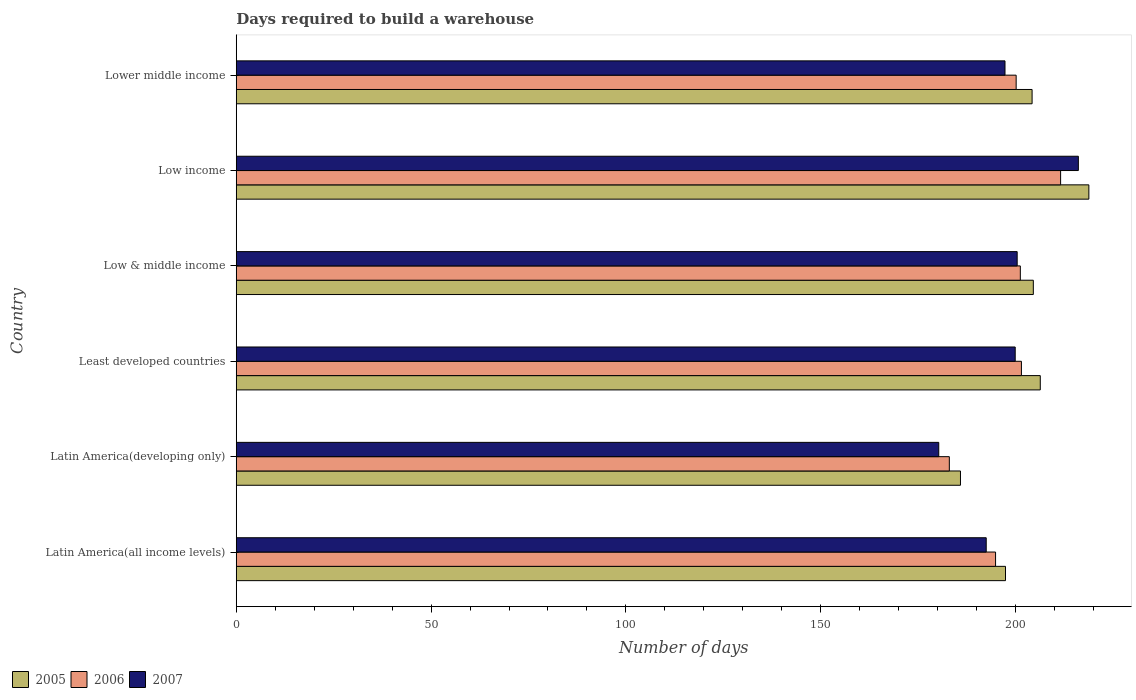Are the number of bars per tick equal to the number of legend labels?
Provide a short and direct response. Yes. Are the number of bars on each tick of the Y-axis equal?
Provide a short and direct response. Yes. How many bars are there on the 4th tick from the top?
Offer a terse response. 3. How many bars are there on the 3rd tick from the bottom?
Make the answer very short. 3. What is the label of the 1st group of bars from the top?
Your answer should be compact. Lower middle income. What is the days required to build a warehouse in in 2007 in Least developed countries?
Your answer should be very brief. 199.9. Across all countries, what is the maximum days required to build a warehouse in in 2007?
Offer a terse response. 216.11. Across all countries, what is the minimum days required to build a warehouse in in 2006?
Offer a terse response. 183. In which country was the days required to build a warehouse in in 2006 maximum?
Ensure brevity in your answer.  Low income. In which country was the days required to build a warehouse in in 2005 minimum?
Offer a terse response. Latin America(developing only). What is the total days required to build a warehouse in in 2007 in the graph?
Offer a very short reply. 1186.46. What is the difference between the days required to build a warehouse in in 2005 in Latin America(all income levels) and that in Low income?
Your answer should be compact. -21.39. What is the difference between the days required to build a warehouse in in 2007 in Lower middle income and the days required to build a warehouse in in 2005 in Least developed countries?
Provide a short and direct response. -9.06. What is the average days required to build a warehouse in in 2006 per country?
Your answer should be very brief. 198.71. What is the difference between the days required to build a warehouse in in 2007 and days required to build a warehouse in in 2005 in Lower middle income?
Offer a terse response. -6.95. In how many countries, is the days required to build a warehouse in in 2007 greater than 110 days?
Ensure brevity in your answer.  6. What is the ratio of the days required to build a warehouse in in 2006 in Latin America(all income levels) to that in Low & middle income?
Keep it short and to the point. 0.97. Is the difference between the days required to build a warehouse in in 2007 in Latin America(all income levels) and Low income greater than the difference between the days required to build a warehouse in in 2005 in Latin America(all income levels) and Low income?
Your answer should be very brief. No. What is the difference between the highest and the second highest days required to build a warehouse in in 2005?
Provide a succinct answer. 12.47. What is the difference between the highest and the lowest days required to build a warehouse in in 2006?
Your answer should be very brief. 28.56. In how many countries, is the days required to build a warehouse in in 2005 greater than the average days required to build a warehouse in in 2005 taken over all countries?
Ensure brevity in your answer.  4. Is it the case that in every country, the sum of the days required to build a warehouse in in 2006 and days required to build a warehouse in in 2005 is greater than the days required to build a warehouse in in 2007?
Provide a short and direct response. Yes. What is the difference between two consecutive major ticks on the X-axis?
Provide a short and direct response. 50. Are the values on the major ticks of X-axis written in scientific E-notation?
Your answer should be very brief. No. Does the graph contain grids?
Keep it short and to the point. No. Where does the legend appear in the graph?
Provide a succinct answer. Bottom left. What is the title of the graph?
Keep it short and to the point. Days required to build a warehouse. What is the label or title of the X-axis?
Your answer should be compact. Number of days. What is the label or title of the Y-axis?
Provide a succinct answer. Country. What is the Number of days of 2005 in Latin America(all income levels)?
Provide a succinct answer. 197.41. What is the Number of days in 2006 in Latin America(all income levels)?
Make the answer very short. 194.86. What is the Number of days of 2007 in Latin America(all income levels)?
Make the answer very short. 192.47. What is the Number of days in 2005 in Latin America(developing only)?
Make the answer very short. 185.86. What is the Number of days of 2006 in Latin America(developing only)?
Your response must be concise. 183. What is the Number of days in 2007 in Latin America(developing only)?
Provide a short and direct response. 180.29. What is the Number of days in 2005 in Least developed countries?
Give a very brief answer. 206.34. What is the Number of days of 2006 in Least developed countries?
Give a very brief answer. 201.5. What is the Number of days of 2007 in Least developed countries?
Provide a short and direct response. 199.9. What is the Number of days of 2005 in Low & middle income?
Your answer should be compact. 204.56. What is the Number of days of 2006 in Low & middle income?
Give a very brief answer. 201.22. What is the Number of days of 2007 in Low & middle income?
Make the answer very short. 200.41. What is the Number of days of 2005 in Low income?
Your answer should be very brief. 218.81. What is the Number of days of 2006 in Low income?
Keep it short and to the point. 211.56. What is the Number of days in 2007 in Low income?
Offer a terse response. 216.11. What is the Number of days of 2005 in Lower middle income?
Your answer should be very brief. 204.24. What is the Number of days in 2006 in Lower middle income?
Keep it short and to the point. 200.15. What is the Number of days of 2007 in Lower middle income?
Keep it short and to the point. 197.28. Across all countries, what is the maximum Number of days in 2005?
Your answer should be compact. 218.81. Across all countries, what is the maximum Number of days in 2006?
Your response must be concise. 211.56. Across all countries, what is the maximum Number of days of 2007?
Ensure brevity in your answer.  216.11. Across all countries, what is the minimum Number of days of 2005?
Provide a short and direct response. 185.86. Across all countries, what is the minimum Number of days in 2006?
Your answer should be compact. 183. Across all countries, what is the minimum Number of days of 2007?
Your answer should be very brief. 180.29. What is the total Number of days of 2005 in the graph?
Your response must be concise. 1217.22. What is the total Number of days in 2006 in the graph?
Make the answer very short. 1192.29. What is the total Number of days in 2007 in the graph?
Make the answer very short. 1186.46. What is the difference between the Number of days in 2005 in Latin America(all income levels) and that in Latin America(developing only)?
Provide a short and direct response. 11.56. What is the difference between the Number of days of 2006 in Latin America(all income levels) and that in Latin America(developing only)?
Your response must be concise. 11.86. What is the difference between the Number of days in 2007 in Latin America(all income levels) and that in Latin America(developing only)?
Your response must be concise. 12.18. What is the difference between the Number of days in 2005 in Latin America(all income levels) and that in Least developed countries?
Keep it short and to the point. -8.93. What is the difference between the Number of days of 2006 in Latin America(all income levels) and that in Least developed countries?
Give a very brief answer. -6.64. What is the difference between the Number of days of 2007 in Latin America(all income levels) and that in Least developed countries?
Your answer should be compact. -7.44. What is the difference between the Number of days in 2005 in Latin America(all income levels) and that in Low & middle income?
Offer a very short reply. -7.14. What is the difference between the Number of days in 2006 in Latin America(all income levels) and that in Low & middle income?
Provide a short and direct response. -6.36. What is the difference between the Number of days in 2007 in Latin America(all income levels) and that in Low & middle income?
Keep it short and to the point. -7.94. What is the difference between the Number of days of 2005 in Latin America(all income levels) and that in Low income?
Provide a short and direct response. -21.39. What is the difference between the Number of days of 2006 in Latin America(all income levels) and that in Low income?
Your answer should be very brief. -16.69. What is the difference between the Number of days in 2007 in Latin America(all income levels) and that in Low income?
Give a very brief answer. -23.64. What is the difference between the Number of days of 2005 in Latin America(all income levels) and that in Lower middle income?
Your answer should be very brief. -6.82. What is the difference between the Number of days in 2006 in Latin America(all income levels) and that in Lower middle income?
Offer a very short reply. -5.29. What is the difference between the Number of days of 2007 in Latin America(all income levels) and that in Lower middle income?
Your answer should be very brief. -4.82. What is the difference between the Number of days in 2005 in Latin America(developing only) and that in Least developed countries?
Provide a short and direct response. -20.48. What is the difference between the Number of days of 2006 in Latin America(developing only) and that in Least developed countries?
Offer a terse response. -18.5. What is the difference between the Number of days of 2007 in Latin America(developing only) and that in Least developed countries?
Give a very brief answer. -19.62. What is the difference between the Number of days of 2005 in Latin America(developing only) and that in Low & middle income?
Provide a succinct answer. -18.7. What is the difference between the Number of days in 2006 in Latin America(developing only) and that in Low & middle income?
Ensure brevity in your answer.  -18.22. What is the difference between the Number of days in 2007 in Latin America(developing only) and that in Low & middle income?
Your answer should be compact. -20.12. What is the difference between the Number of days in 2005 in Latin America(developing only) and that in Low income?
Provide a short and direct response. -32.95. What is the difference between the Number of days in 2006 in Latin America(developing only) and that in Low income?
Provide a succinct answer. -28.56. What is the difference between the Number of days of 2007 in Latin America(developing only) and that in Low income?
Give a very brief answer. -35.83. What is the difference between the Number of days of 2005 in Latin America(developing only) and that in Lower middle income?
Provide a short and direct response. -18.38. What is the difference between the Number of days in 2006 in Latin America(developing only) and that in Lower middle income?
Make the answer very short. -17.15. What is the difference between the Number of days in 2007 in Latin America(developing only) and that in Lower middle income?
Offer a terse response. -17. What is the difference between the Number of days in 2005 in Least developed countries and that in Low & middle income?
Your answer should be compact. 1.78. What is the difference between the Number of days of 2006 in Least developed countries and that in Low & middle income?
Provide a short and direct response. 0.28. What is the difference between the Number of days in 2007 in Least developed countries and that in Low & middle income?
Offer a very short reply. -0.5. What is the difference between the Number of days in 2005 in Least developed countries and that in Low income?
Your answer should be compact. -12.47. What is the difference between the Number of days in 2006 in Least developed countries and that in Low income?
Your response must be concise. -10.06. What is the difference between the Number of days of 2007 in Least developed countries and that in Low income?
Your answer should be compact. -16.21. What is the difference between the Number of days of 2005 in Least developed countries and that in Lower middle income?
Your answer should be compact. 2.1. What is the difference between the Number of days in 2006 in Least developed countries and that in Lower middle income?
Offer a terse response. 1.35. What is the difference between the Number of days of 2007 in Least developed countries and that in Lower middle income?
Provide a succinct answer. 2.62. What is the difference between the Number of days of 2005 in Low & middle income and that in Low income?
Provide a short and direct response. -14.25. What is the difference between the Number of days of 2006 in Low & middle income and that in Low income?
Make the answer very short. -10.34. What is the difference between the Number of days in 2007 in Low & middle income and that in Low income?
Make the answer very short. -15.7. What is the difference between the Number of days in 2005 in Low & middle income and that in Lower middle income?
Offer a very short reply. 0.32. What is the difference between the Number of days of 2006 in Low & middle income and that in Lower middle income?
Offer a terse response. 1.07. What is the difference between the Number of days in 2007 in Low & middle income and that in Lower middle income?
Your response must be concise. 3.13. What is the difference between the Number of days in 2005 in Low income and that in Lower middle income?
Offer a very short reply. 14.57. What is the difference between the Number of days of 2006 in Low income and that in Lower middle income?
Offer a terse response. 11.41. What is the difference between the Number of days of 2007 in Low income and that in Lower middle income?
Keep it short and to the point. 18.83. What is the difference between the Number of days in 2005 in Latin America(all income levels) and the Number of days in 2006 in Latin America(developing only)?
Give a very brief answer. 14.41. What is the difference between the Number of days of 2005 in Latin America(all income levels) and the Number of days of 2007 in Latin America(developing only)?
Your answer should be compact. 17.13. What is the difference between the Number of days of 2006 in Latin America(all income levels) and the Number of days of 2007 in Latin America(developing only)?
Offer a terse response. 14.58. What is the difference between the Number of days in 2005 in Latin America(all income levels) and the Number of days in 2006 in Least developed countries?
Give a very brief answer. -4.09. What is the difference between the Number of days of 2005 in Latin America(all income levels) and the Number of days of 2007 in Least developed countries?
Ensure brevity in your answer.  -2.49. What is the difference between the Number of days in 2006 in Latin America(all income levels) and the Number of days in 2007 in Least developed countries?
Provide a short and direct response. -5.04. What is the difference between the Number of days in 2005 in Latin America(all income levels) and the Number of days in 2006 in Low & middle income?
Ensure brevity in your answer.  -3.81. What is the difference between the Number of days in 2005 in Latin America(all income levels) and the Number of days in 2007 in Low & middle income?
Ensure brevity in your answer.  -3. What is the difference between the Number of days in 2006 in Latin America(all income levels) and the Number of days in 2007 in Low & middle income?
Provide a succinct answer. -5.55. What is the difference between the Number of days in 2005 in Latin America(all income levels) and the Number of days in 2006 in Low income?
Offer a terse response. -14.14. What is the difference between the Number of days of 2005 in Latin America(all income levels) and the Number of days of 2007 in Low income?
Give a very brief answer. -18.7. What is the difference between the Number of days of 2006 in Latin America(all income levels) and the Number of days of 2007 in Low income?
Your response must be concise. -21.25. What is the difference between the Number of days of 2005 in Latin America(all income levels) and the Number of days of 2006 in Lower middle income?
Keep it short and to the point. -2.73. What is the difference between the Number of days in 2005 in Latin America(all income levels) and the Number of days in 2007 in Lower middle income?
Your response must be concise. 0.13. What is the difference between the Number of days in 2006 in Latin America(all income levels) and the Number of days in 2007 in Lower middle income?
Your answer should be compact. -2.42. What is the difference between the Number of days in 2005 in Latin America(developing only) and the Number of days in 2006 in Least developed countries?
Give a very brief answer. -15.64. What is the difference between the Number of days of 2005 in Latin America(developing only) and the Number of days of 2007 in Least developed countries?
Keep it short and to the point. -14.05. What is the difference between the Number of days in 2006 in Latin America(developing only) and the Number of days in 2007 in Least developed countries?
Your answer should be very brief. -16.9. What is the difference between the Number of days in 2005 in Latin America(developing only) and the Number of days in 2006 in Low & middle income?
Provide a short and direct response. -15.36. What is the difference between the Number of days in 2005 in Latin America(developing only) and the Number of days in 2007 in Low & middle income?
Offer a terse response. -14.55. What is the difference between the Number of days in 2006 in Latin America(developing only) and the Number of days in 2007 in Low & middle income?
Keep it short and to the point. -17.41. What is the difference between the Number of days of 2005 in Latin America(developing only) and the Number of days of 2006 in Low income?
Offer a very short reply. -25.7. What is the difference between the Number of days of 2005 in Latin America(developing only) and the Number of days of 2007 in Low income?
Make the answer very short. -30.25. What is the difference between the Number of days in 2006 in Latin America(developing only) and the Number of days in 2007 in Low income?
Your answer should be very brief. -33.11. What is the difference between the Number of days of 2005 in Latin America(developing only) and the Number of days of 2006 in Lower middle income?
Your answer should be very brief. -14.29. What is the difference between the Number of days of 2005 in Latin America(developing only) and the Number of days of 2007 in Lower middle income?
Give a very brief answer. -11.43. What is the difference between the Number of days in 2006 in Latin America(developing only) and the Number of days in 2007 in Lower middle income?
Keep it short and to the point. -14.28. What is the difference between the Number of days of 2005 in Least developed countries and the Number of days of 2006 in Low & middle income?
Your response must be concise. 5.12. What is the difference between the Number of days in 2005 in Least developed countries and the Number of days in 2007 in Low & middle income?
Provide a succinct answer. 5.93. What is the difference between the Number of days in 2006 in Least developed countries and the Number of days in 2007 in Low & middle income?
Provide a short and direct response. 1.09. What is the difference between the Number of days of 2005 in Least developed countries and the Number of days of 2006 in Low income?
Provide a succinct answer. -5.21. What is the difference between the Number of days in 2005 in Least developed countries and the Number of days in 2007 in Low income?
Provide a short and direct response. -9.77. What is the difference between the Number of days of 2006 in Least developed countries and the Number of days of 2007 in Low income?
Ensure brevity in your answer.  -14.61. What is the difference between the Number of days in 2005 in Least developed countries and the Number of days in 2006 in Lower middle income?
Keep it short and to the point. 6.19. What is the difference between the Number of days of 2005 in Least developed countries and the Number of days of 2007 in Lower middle income?
Ensure brevity in your answer.  9.06. What is the difference between the Number of days in 2006 in Least developed countries and the Number of days in 2007 in Lower middle income?
Your response must be concise. 4.22. What is the difference between the Number of days in 2005 in Low & middle income and the Number of days in 2006 in Low income?
Keep it short and to the point. -7. What is the difference between the Number of days of 2005 in Low & middle income and the Number of days of 2007 in Low income?
Give a very brief answer. -11.55. What is the difference between the Number of days of 2006 in Low & middle income and the Number of days of 2007 in Low income?
Provide a succinct answer. -14.89. What is the difference between the Number of days of 2005 in Low & middle income and the Number of days of 2006 in Lower middle income?
Offer a very short reply. 4.41. What is the difference between the Number of days in 2005 in Low & middle income and the Number of days in 2007 in Lower middle income?
Your response must be concise. 7.27. What is the difference between the Number of days of 2006 in Low & middle income and the Number of days of 2007 in Lower middle income?
Make the answer very short. 3.94. What is the difference between the Number of days of 2005 in Low income and the Number of days of 2006 in Lower middle income?
Your answer should be compact. 18.66. What is the difference between the Number of days of 2005 in Low income and the Number of days of 2007 in Lower middle income?
Your answer should be very brief. 21.52. What is the difference between the Number of days in 2006 in Low income and the Number of days in 2007 in Lower middle income?
Make the answer very short. 14.27. What is the average Number of days in 2005 per country?
Provide a short and direct response. 202.87. What is the average Number of days of 2006 per country?
Make the answer very short. 198.71. What is the average Number of days of 2007 per country?
Ensure brevity in your answer.  197.74. What is the difference between the Number of days of 2005 and Number of days of 2006 in Latin America(all income levels)?
Offer a very short reply. 2.55. What is the difference between the Number of days of 2005 and Number of days of 2007 in Latin America(all income levels)?
Provide a short and direct response. 4.95. What is the difference between the Number of days of 2006 and Number of days of 2007 in Latin America(all income levels)?
Your answer should be very brief. 2.4. What is the difference between the Number of days of 2005 and Number of days of 2006 in Latin America(developing only)?
Provide a succinct answer. 2.86. What is the difference between the Number of days of 2005 and Number of days of 2007 in Latin America(developing only)?
Keep it short and to the point. 5.57. What is the difference between the Number of days of 2006 and Number of days of 2007 in Latin America(developing only)?
Provide a short and direct response. 2.71. What is the difference between the Number of days in 2005 and Number of days in 2006 in Least developed countries?
Offer a terse response. 4.84. What is the difference between the Number of days of 2005 and Number of days of 2007 in Least developed countries?
Your response must be concise. 6.44. What is the difference between the Number of days in 2006 and Number of days in 2007 in Least developed countries?
Provide a succinct answer. 1.6. What is the difference between the Number of days in 2005 and Number of days in 2006 in Low & middle income?
Provide a short and direct response. 3.34. What is the difference between the Number of days of 2005 and Number of days of 2007 in Low & middle income?
Your answer should be very brief. 4.15. What is the difference between the Number of days of 2006 and Number of days of 2007 in Low & middle income?
Offer a terse response. 0.81. What is the difference between the Number of days of 2005 and Number of days of 2006 in Low income?
Make the answer very short. 7.25. What is the difference between the Number of days of 2005 and Number of days of 2007 in Low income?
Your response must be concise. 2.7. What is the difference between the Number of days in 2006 and Number of days in 2007 in Low income?
Your answer should be compact. -4.56. What is the difference between the Number of days in 2005 and Number of days in 2006 in Lower middle income?
Offer a terse response. 4.09. What is the difference between the Number of days of 2005 and Number of days of 2007 in Lower middle income?
Your answer should be compact. 6.95. What is the difference between the Number of days of 2006 and Number of days of 2007 in Lower middle income?
Ensure brevity in your answer.  2.86. What is the ratio of the Number of days in 2005 in Latin America(all income levels) to that in Latin America(developing only)?
Offer a very short reply. 1.06. What is the ratio of the Number of days of 2006 in Latin America(all income levels) to that in Latin America(developing only)?
Your response must be concise. 1.06. What is the ratio of the Number of days of 2007 in Latin America(all income levels) to that in Latin America(developing only)?
Offer a very short reply. 1.07. What is the ratio of the Number of days in 2005 in Latin America(all income levels) to that in Least developed countries?
Offer a terse response. 0.96. What is the ratio of the Number of days in 2006 in Latin America(all income levels) to that in Least developed countries?
Offer a very short reply. 0.97. What is the ratio of the Number of days in 2007 in Latin America(all income levels) to that in Least developed countries?
Give a very brief answer. 0.96. What is the ratio of the Number of days in 2005 in Latin America(all income levels) to that in Low & middle income?
Ensure brevity in your answer.  0.97. What is the ratio of the Number of days of 2006 in Latin America(all income levels) to that in Low & middle income?
Provide a succinct answer. 0.97. What is the ratio of the Number of days in 2007 in Latin America(all income levels) to that in Low & middle income?
Give a very brief answer. 0.96. What is the ratio of the Number of days in 2005 in Latin America(all income levels) to that in Low income?
Offer a very short reply. 0.9. What is the ratio of the Number of days of 2006 in Latin America(all income levels) to that in Low income?
Offer a terse response. 0.92. What is the ratio of the Number of days of 2007 in Latin America(all income levels) to that in Low income?
Offer a very short reply. 0.89. What is the ratio of the Number of days in 2005 in Latin America(all income levels) to that in Lower middle income?
Your answer should be compact. 0.97. What is the ratio of the Number of days of 2006 in Latin America(all income levels) to that in Lower middle income?
Provide a succinct answer. 0.97. What is the ratio of the Number of days of 2007 in Latin America(all income levels) to that in Lower middle income?
Your answer should be very brief. 0.98. What is the ratio of the Number of days in 2005 in Latin America(developing only) to that in Least developed countries?
Keep it short and to the point. 0.9. What is the ratio of the Number of days in 2006 in Latin America(developing only) to that in Least developed countries?
Provide a short and direct response. 0.91. What is the ratio of the Number of days of 2007 in Latin America(developing only) to that in Least developed countries?
Your answer should be compact. 0.9. What is the ratio of the Number of days in 2005 in Latin America(developing only) to that in Low & middle income?
Provide a short and direct response. 0.91. What is the ratio of the Number of days of 2006 in Latin America(developing only) to that in Low & middle income?
Provide a succinct answer. 0.91. What is the ratio of the Number of days in 2007 in Latin America(developing only) to that in Low & middle income?
Ensure brevity in your answer.  0.9. What is the ratio of the Number of days of 2005 in Latin America(developing only) to that in Low income?
Provide a succinct answer. 0.85. What is the ratio of the Number of days in 2006 in Latin America(developing only) to that in Low income?
Your answer should be compact. 0.86. What is the ratio of the Number of days in 2007 in Latin America(developing only) to that in Low income?
Keep it short and to the point. 0.83. What is the ratio of the Number of days of 2005 in Latin America(developing only) to that in Lower middle income?
Give a very brief answer. 0.91. What is the ratio of the Number of days of 2006 in Latin America(developing only) to that in Lower middle income?
Make the answer very short. 0.91. What is the ratio of the Number of days of 2007 in Latin America(developing only) to that in Lower middle income?
Keep it short and to the point. 0.91. What is the ratio of the Number of days in 2005 in Least developed countries to that in Low & middle income?
Give a very brief answer. 1.01. What is the ratio of the Number of days in 2007 in Least developed countries to that in Low & middle income?
Give a very brief answer. 1. What is the ratio of the Number of days in 2005 in Least developed countries to that in Low income?
Offer a very short reply. 0.94. What is the ratio of the Number of days in 2006 in Least developed countries to that in Low income?
Your answer should be compact. 0.95. What is the ratio of the Number of days of 2007 in Least developed countries to that in Low income?
Offer a very short reply. 0.93. What is the ratio of the Number of days in 2005 in Least developed countries to that in Lower middle income?
Provide a succinct answer. 1.01. What is the ratio of the Number of days of 2006 in Least developed countries to that in Lower middle income?
Ensure brevity in your answer.  1.01. What is the ratio of the Number of days of 2007 in Least developed countries to that in Lower middle income?
Ensure brevity in your answer.  1.01. What is the ratio of the Number of days in 2005 in Low & middle income to that in Low income?
Your answer should be very brief. 0.93. What is the ratio of the Number of days of 2006 in Low & middle income to that in Low income?
Your answer should be compact. 0.95. What is the ratio of the Number of days in 2007 in Low & middle income to that in Low income?
Your response must be concise. 0.93. What is the ratio of the Number of days in 2006 in Low & middle income to that in Lower middle income?
Give a very brief answer. 1.01. What is the ratio of the Number of days of 2007 in Low & middle income to that in Lower middle income?
Ensure brevity in your answer.  1.02. What is the ratio of the Number of days in 2005 in Low income to that in Lower middle income?
Provide a succinct answer. 1.07. What is the ratio of the Number of days in 2006 in Low income to that in Lower middle income?
Keep it short and to the point. 1.06. What is the ratio of the Number of days of 2007 in Low income to that in Lower middle income?
Provide a succinct answer. 1.1. What is the difference between the highest and the second highest Number of days of 2005?
Ensure brevity in your answer.  12.47. What is the difference between the highest and the second highest Number of days in 2006?
Provide a succinct answer. 10.06. What is the difference between the highest and the second highest Number of days of 2007?
Ensure brevity in your answer.  15.7. What is the difference between the highest and the lowest Number of days of 2005?
Keep it short and to the point. 32.95. What is the difference between the highest and the lowest Number of days of 2006?
Make the answer very short. 28.56. What is the difference between the highest and the lowest Number of days in 2007?
Your answer should be compact. 35.83. 